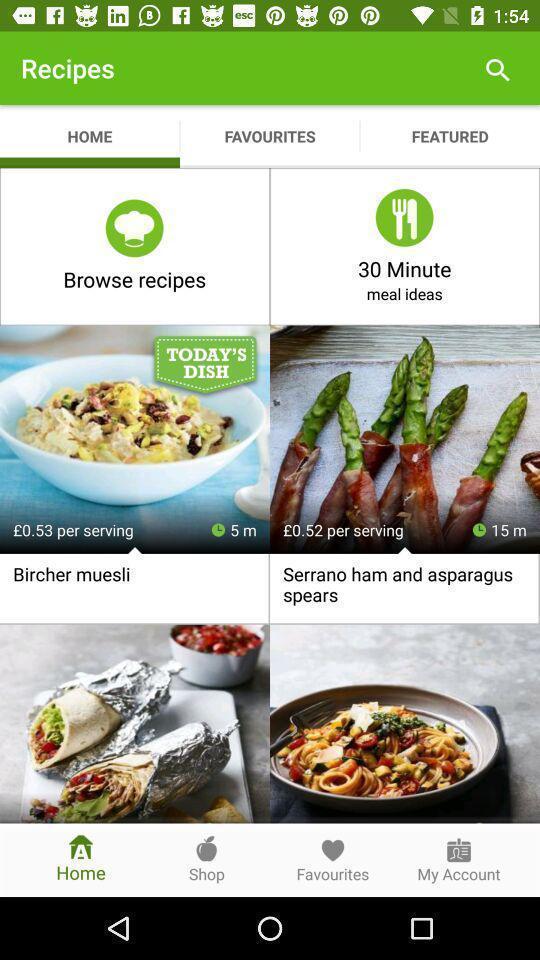Provide a description of this screenshot. Page showing the different recipes. 